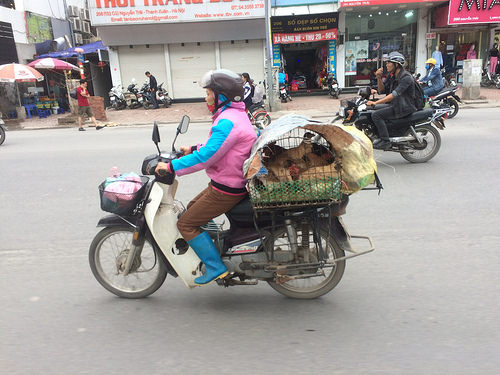<image>
Can you confirm if the bird is on the scooter? Yes. Looking at the image, I can see the bird is positioned on top of the scooter, with the scooter providing support. Is there a man on the bike? No. The man is not positioned on the bike. They may be near each other, but the man is not supported by or resting on top of the bike. Is the bike behind the woman? No. The bike is not behind the woman. From this viewpoint, the bike appears to be positioned elsewhere in the scene. Is the motorbike under the boots? No. The motorbike is not positioned under the boots. The vertical relationship between these objects is different. 